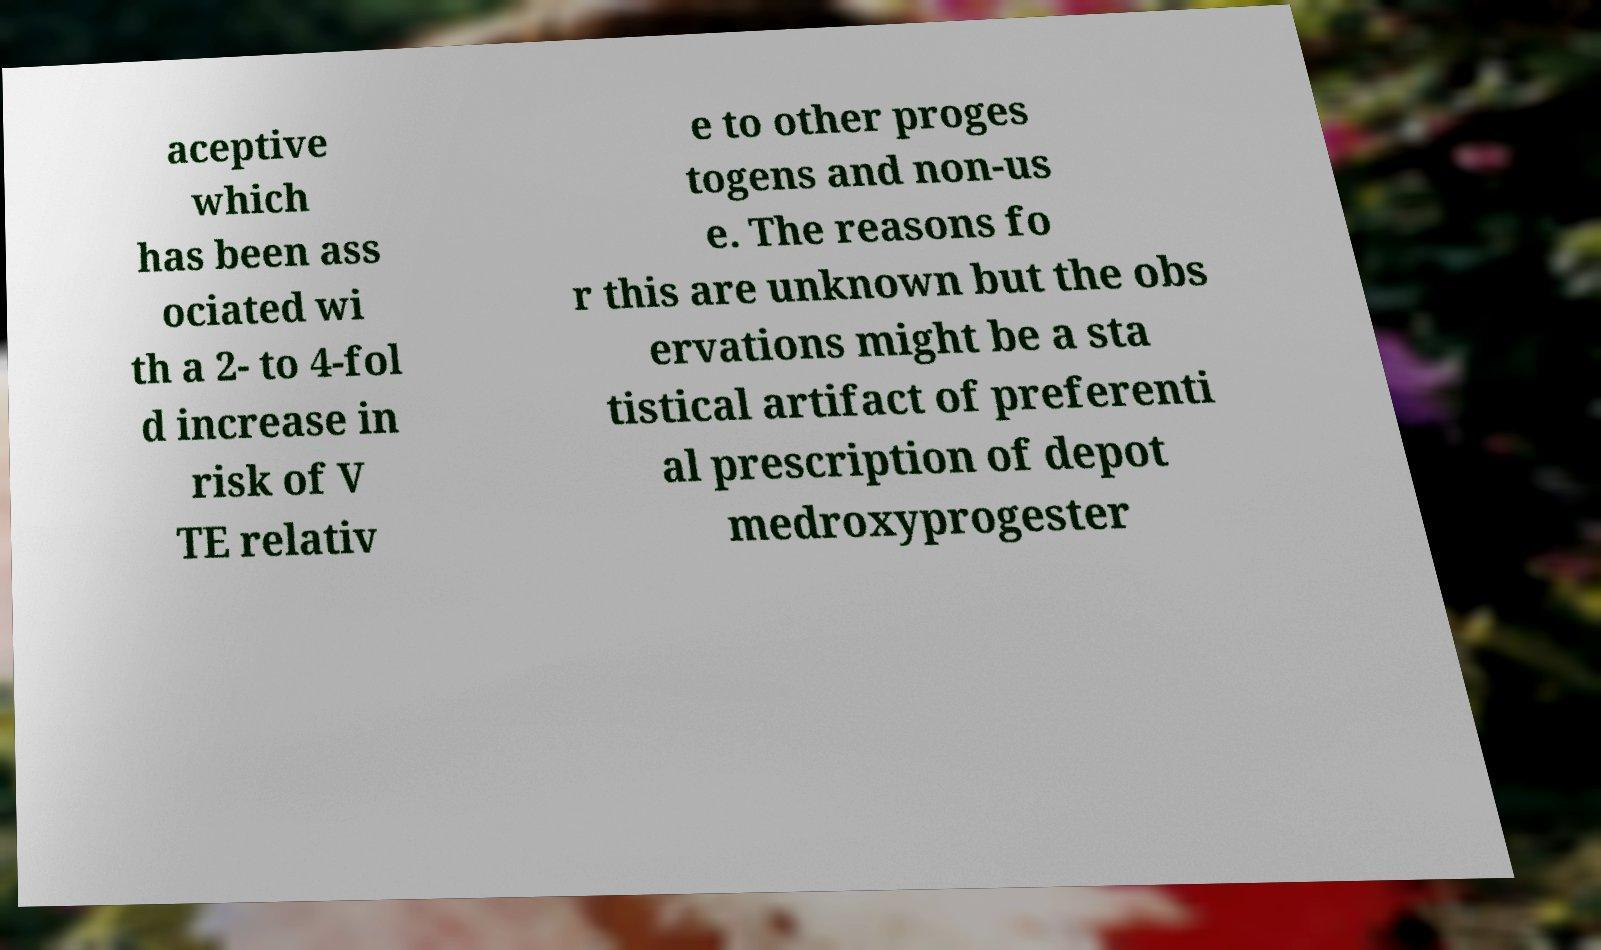Can you read and provide the text displayed in the image?This photo seems to have some interesting text. Can you extract and type it out for me? aceptive which has been ass ociated wi th a 2- to 4-fol d increase in risk of V TE relativ e to other proges togens and non-us e. The reasons fo r this are unknown but the obs ervations might be a sta tistical artifact of preferenti al prescription of depot medroxyprogester 